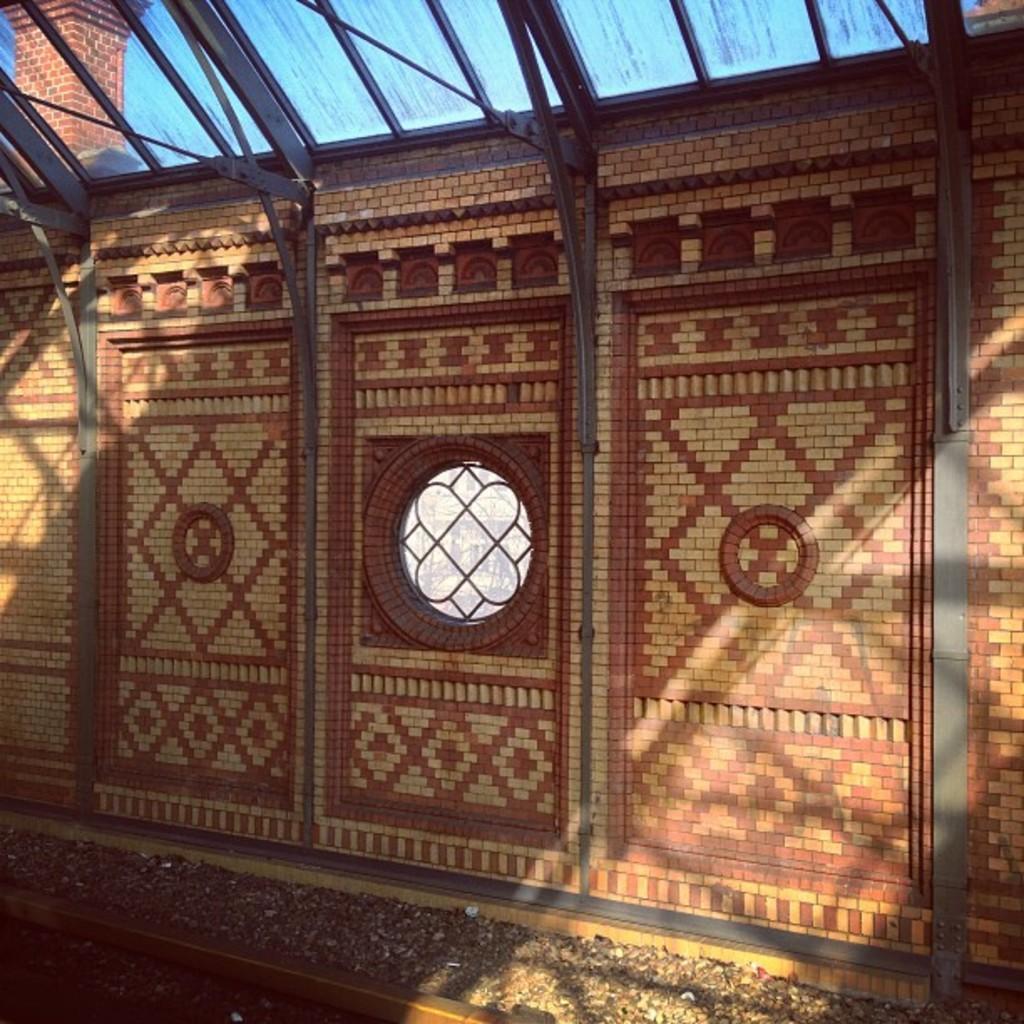Could you give a brief overview of what you see in this image? In this image I can see a wall which is in brown and cream color. I can also see a window. 